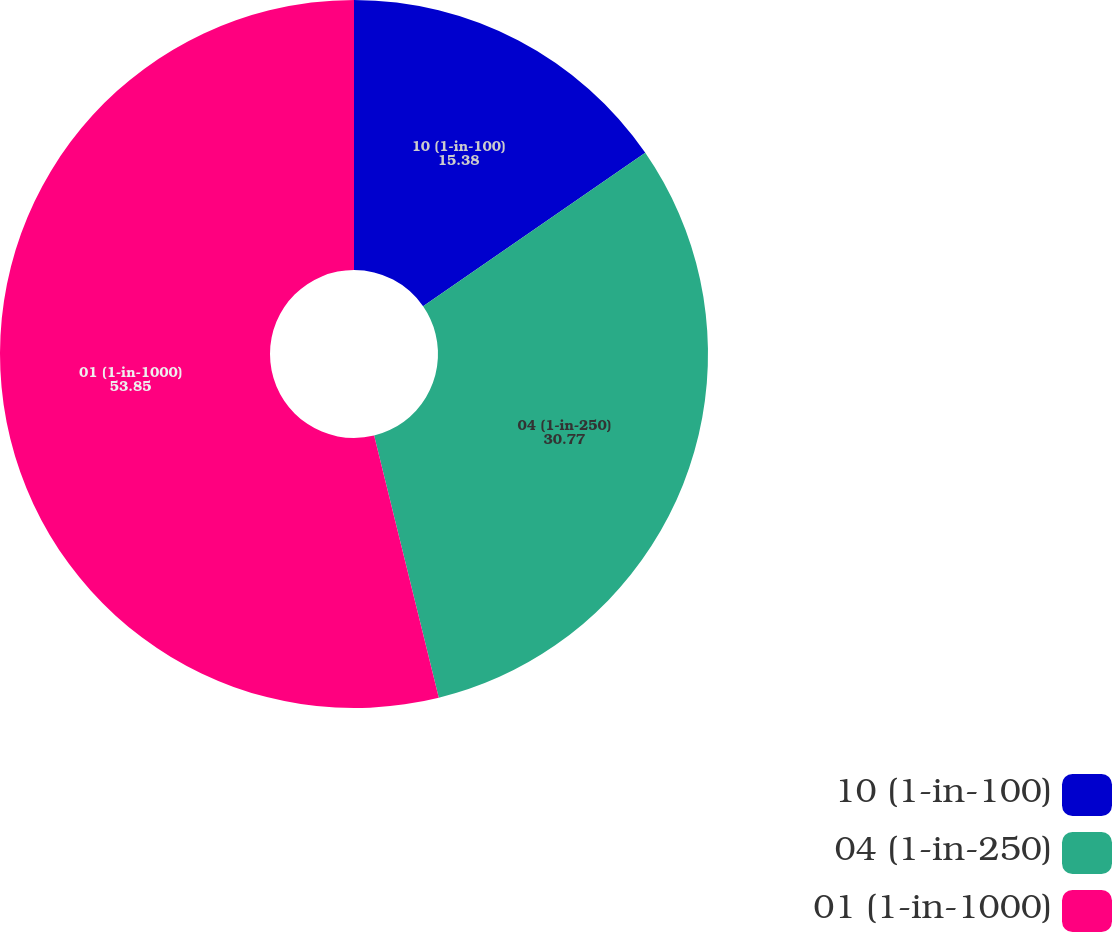<chart> <loc_0><loc_0><loc_500><loc_500><pie_chart><fcel>10 (1-in-100)<fcel>04 (1-in-250)<fcel>01 (1-in-1000)<nl><fcel>15.38%<fcel>30.77%<fcel>53.85%<nl></chart> 